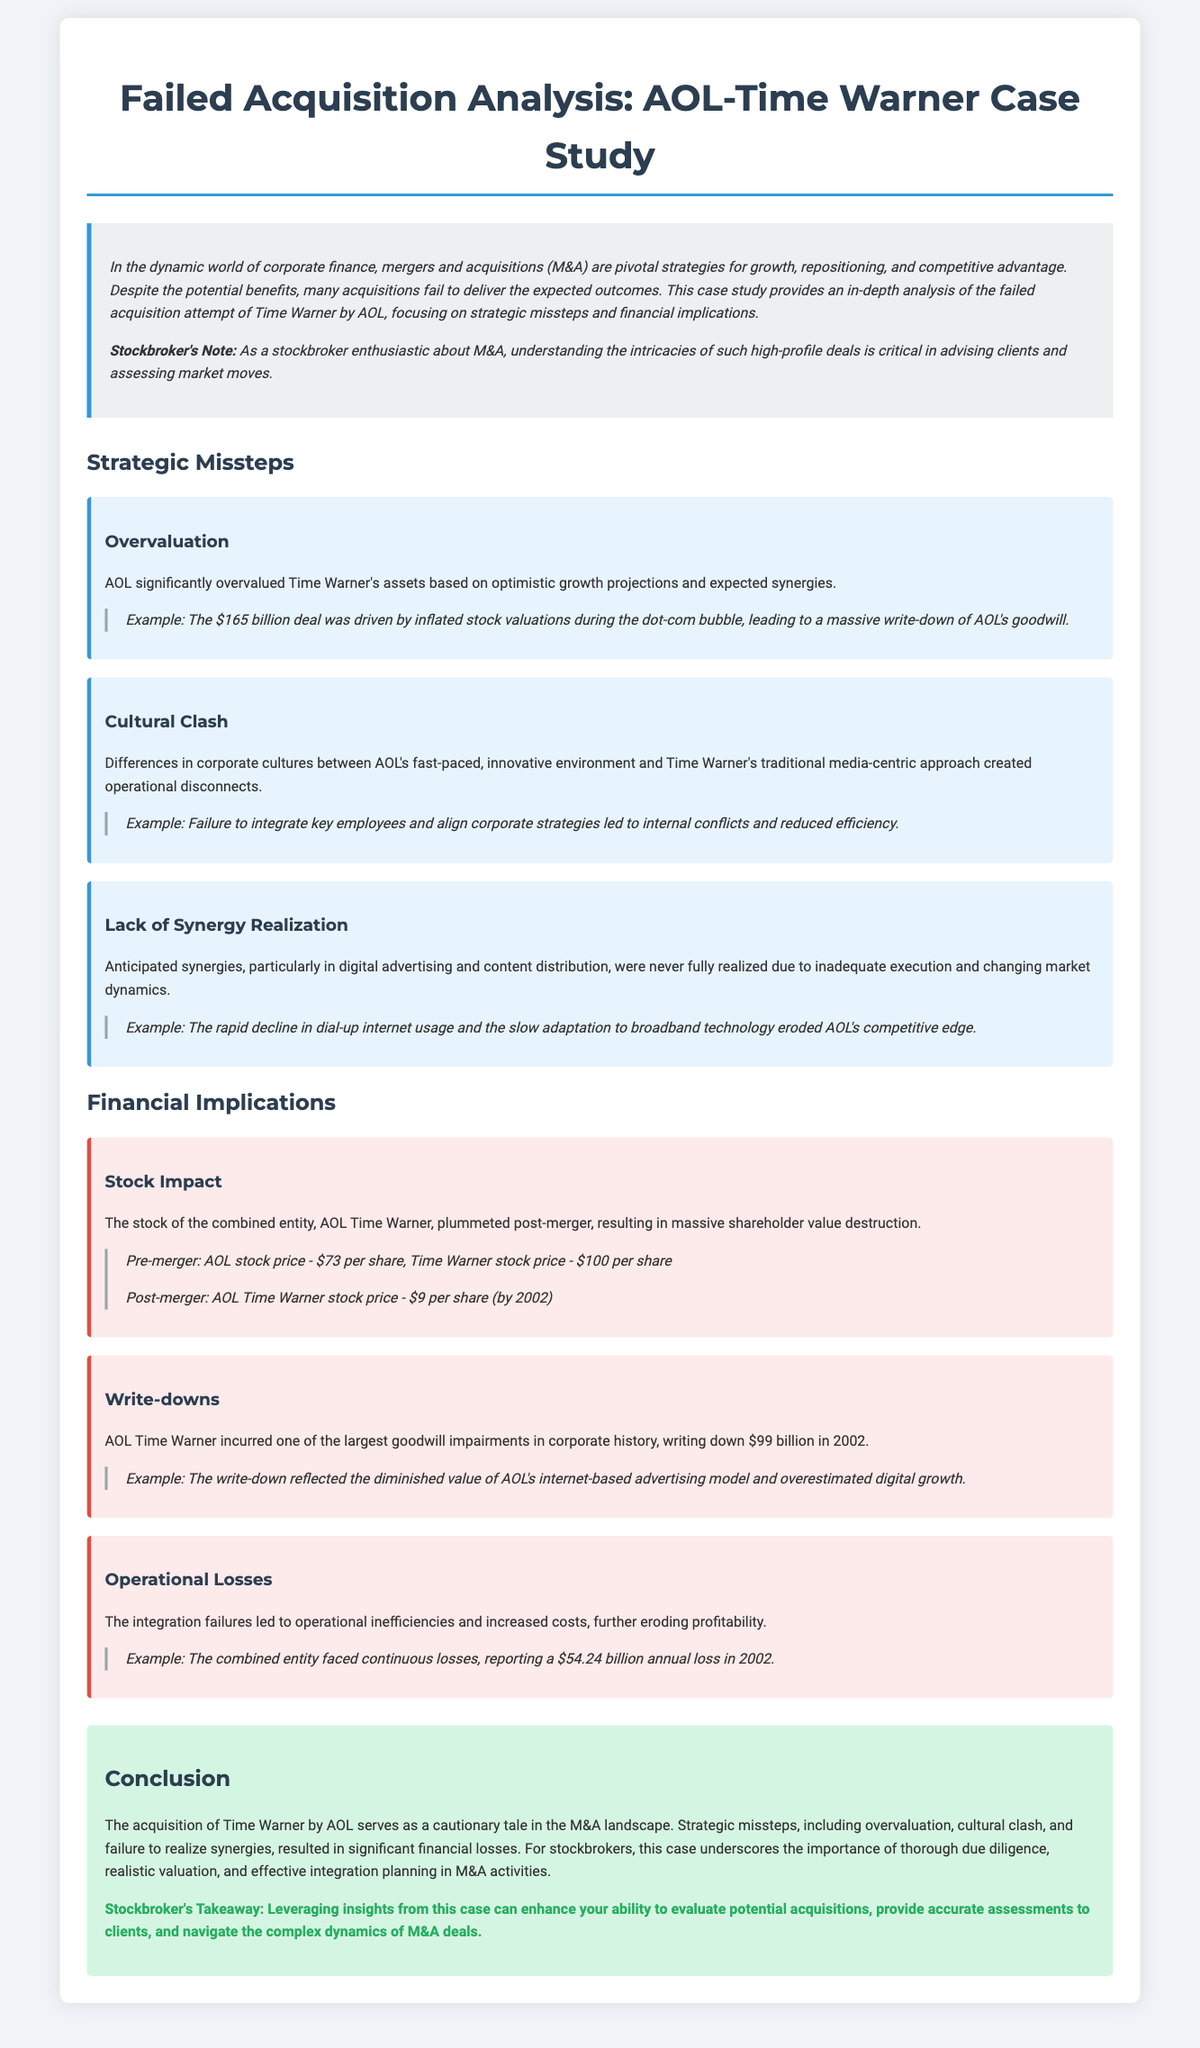What was the value of the AOL-Time Warner merger? The document states that the merger was valued at $165 billion.
Answer: $165 billion What significant financial write-down occurred in 2002? The document mentions a goodwill impairment write-down of $99 billion incurred by AOL Time Warner.
Answer: $99 billion What was AOL's stock price prior to the merger? According to the document, AOL's stock price was $73 per share before the merger.
Answer: $73 per share What kind of cultural differences contributed to the acquisition's failure? The document describes a cultural clash between AOL's fast-paced environment and Time Warner's traditional approach.
Answer: Cultural clash What was a major operational loss reported in 2002? The document notes that the combined entity faced an annual loss of $54.24 billion in 2002.
Answer: $54.24 billion What is one key takeaway for stockbrokers from this case? The document emphasizes the importance of thorough due diligence in M&A activities as a takeaway for stockbrokers.
Answer: Thorough due diligence What was the primary reason behind AOL's overvaluation of Time Warner? The document highlights that AOL's overvaluation was based on optimistic growth projections and expected synergies.
Answer: Optimistic growth projections What does the case study serve as in the M&A landscape? The document refers to the case study as a cautionary tale in the M&A landscape.
Answer: Cautionary tale 